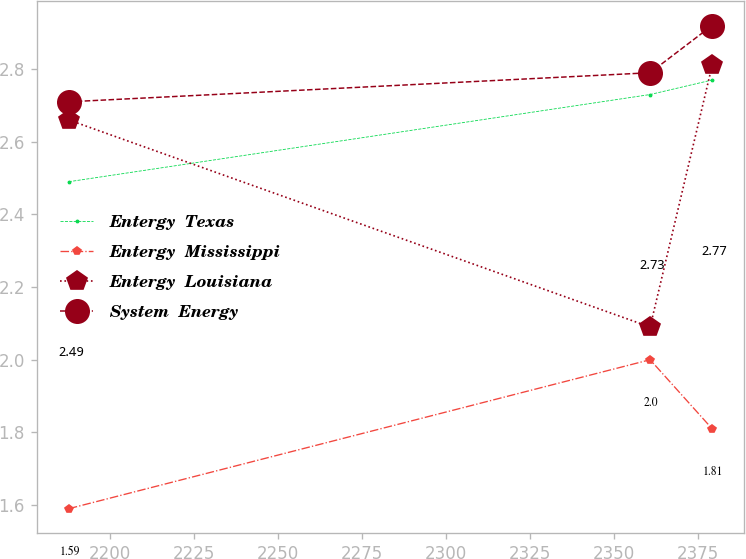Convert chart. <chart><loc_0><loc_0><loc_500><loc_500><line_chart><ecel><fcel>Entergy  Texas<fcel>Entergy  Mississippi<fcel>Entergy  Louisiana<fcel>System  Energy<nl><fcel>2187.63<fcel>2.49<fcel>1.59<fcel>2.66<fcel>2.71<nl><fcel>2360.66<fcel>2.73<fcel>2<fcel>2.09<fcel>2.79<nl><fcel>2379.12<fcel>2.77<fcel>1.81<fcel>2.81<fcel>2.92<nl></chart> 